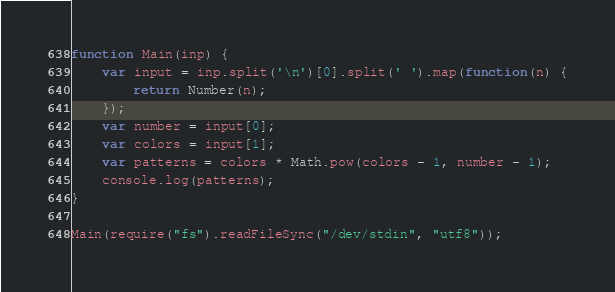Convert code to text. <code><loc_0><loc_0><loc_500><loc_500><_JavaScript_>function Main(inp) {
    var input = inp.split('\n')[0].split(' ').map(function(n) {
        return Number(n);
    });
    var number = input[0];
    var colors = input[1];
    var patterns = colors * Math.pow(colors - 1, number - 1); 
    console.log(patterns);
}

Main(require("fs").readFileSync("/dev/stdin", "utf8"));</code> 